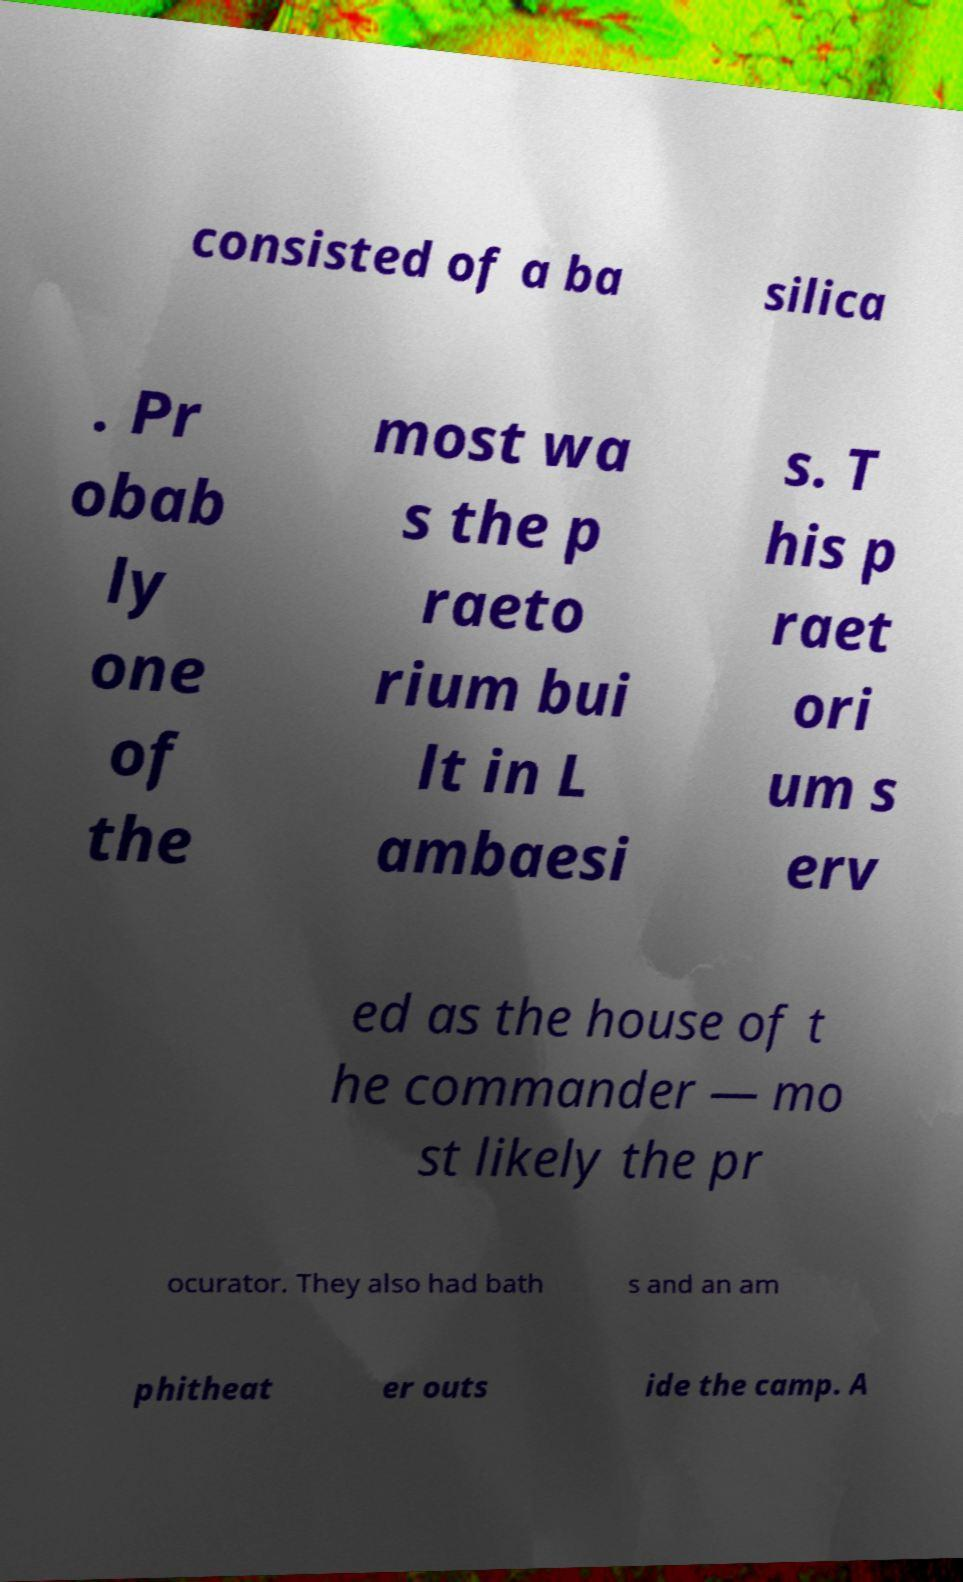Please identify and transcribe the text found in this image. consisted of a ba silica . Pr obab ly one of the most wa s the p raeto rium bui lt in L ambaesi s. T his p raet ori um s erv ed as the house of t he commander — mo st likely the pr ocurator. They also had bath s and an am phitheat er outs ide the camp. A 